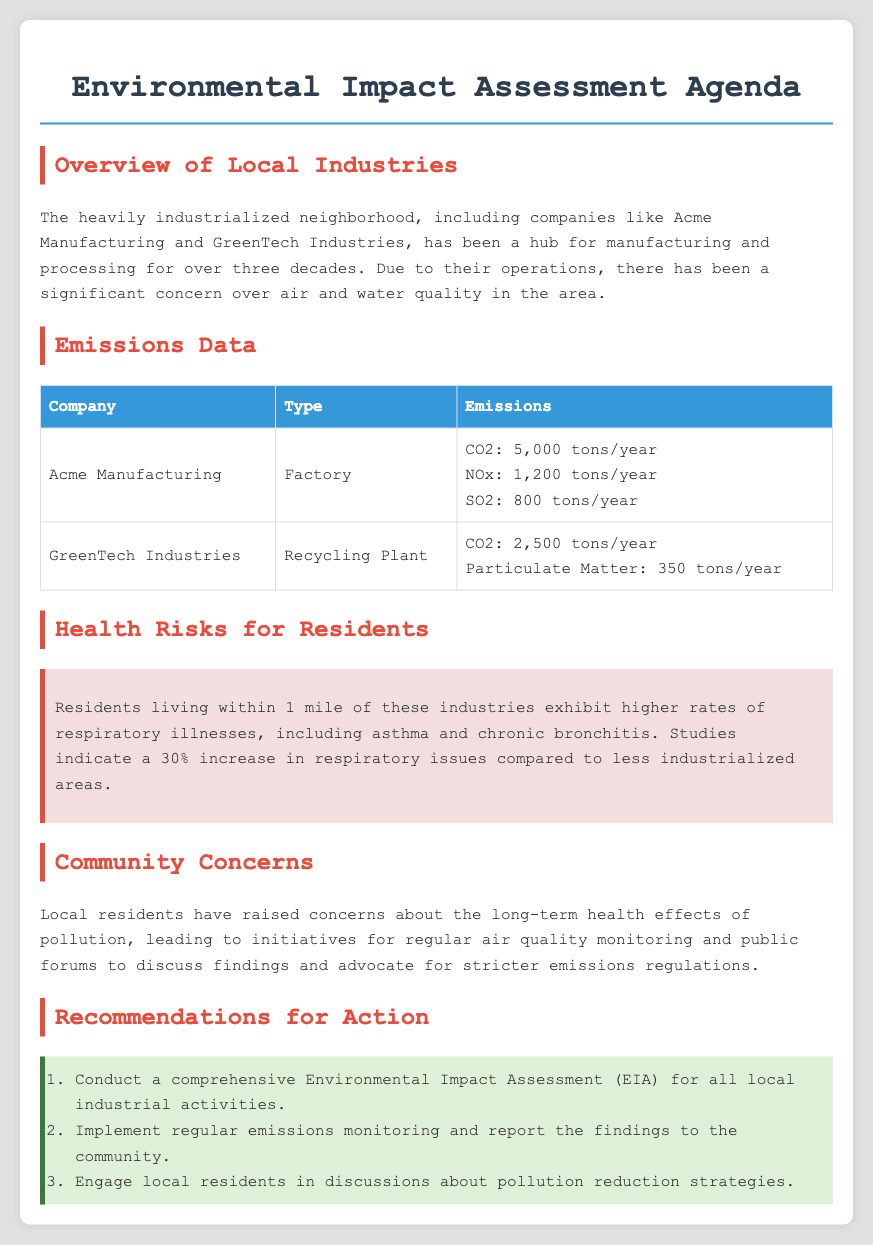What is the primary concern of residents? The primary concern of residents is the long-term health effects of pollution from local industries.
Answer: Long-term health effects of pollution How much CO2 does Acme Manufacturing emit per year? The document specifies that Acme Manufacturing emits 5,000 tons of CO2 each year.
Answer: 5,000 tons/year What percentage increase in respiratory issues is noted for residents? The document states there is a 30% increase in respiratory issues compared to less industrialized areas.
Answer: 30% Which company operates a recycling plant? The agenda mentions GreenTech Industries as the company that operates a recycling plant.
Answer: GreenTech Industries What action is recommended for local industries? The recommendations include conducting a comprehensive Environmental Impact Assessment (EIA) for all local industrial activities.
Answer: Conduct a comprehensive Environmental Impact Assessment (EIA) How many tons of particulate matter does GreenTech Industries emit per year? According to the emissions data, GreenTech Industries emits 350 tons of particulate matter each year.
Answer: 350 tons/year 